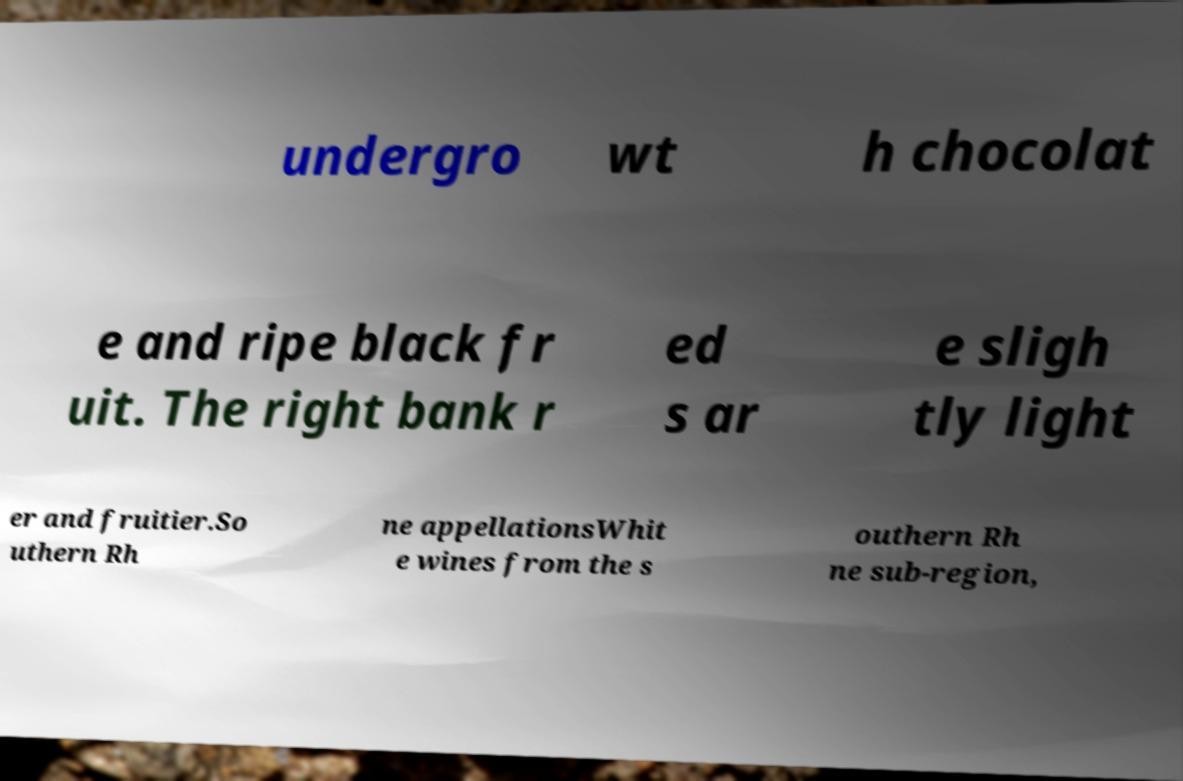Can you accurately transcribe the text from the provided image for me? undergro wt h chocolat e and ripe black fr uit. The right bank r ed s ar e sligh tly light er and fruitier.So uthern Rh ne appellationsWhit e wines from the s outhern Rh ne sub-region, 